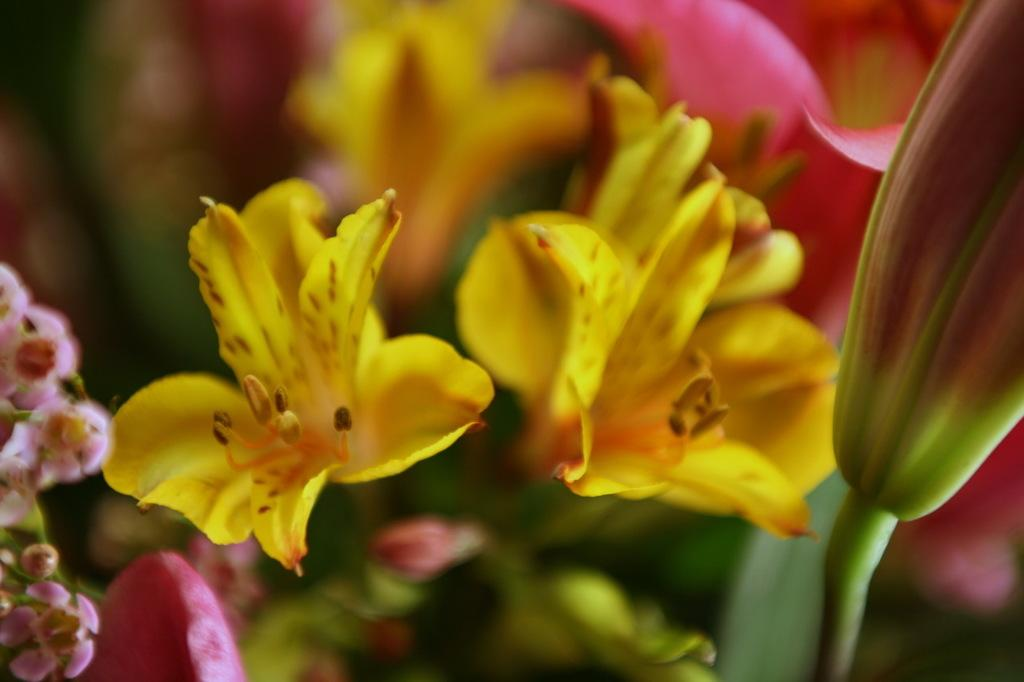What type of living organisms can be seen in the image? There are flowers in the image. Can you describe the background of the image? The background of the image is blurred. What type of secretary is performing an operation in the image? There is no secretary or operation present in the image; it only features flowers and a blurred background. 